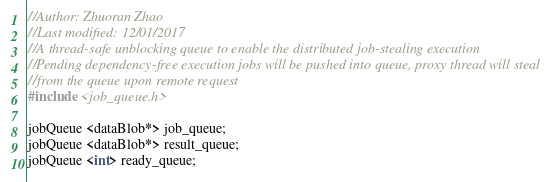Convert code to text. <code><loc_0><loc_0><loc_500><loc_500><_C++_>//Author: Zhuoran Zhao
//Last modified: 12/01/2017
//A thread-safe unblocking queue to enable the distributed job-stealing execution
//Pending dependency-free execution jobs will be pushed into queue, proxy thread will steal
//from the queue upon remote request 
#include <job_queue.h>

jobQueue <dataBlob*> job_queue;
jobQueue <dataBlob*> result_queue;
jobQueue <int> ready_queue;
</code> 